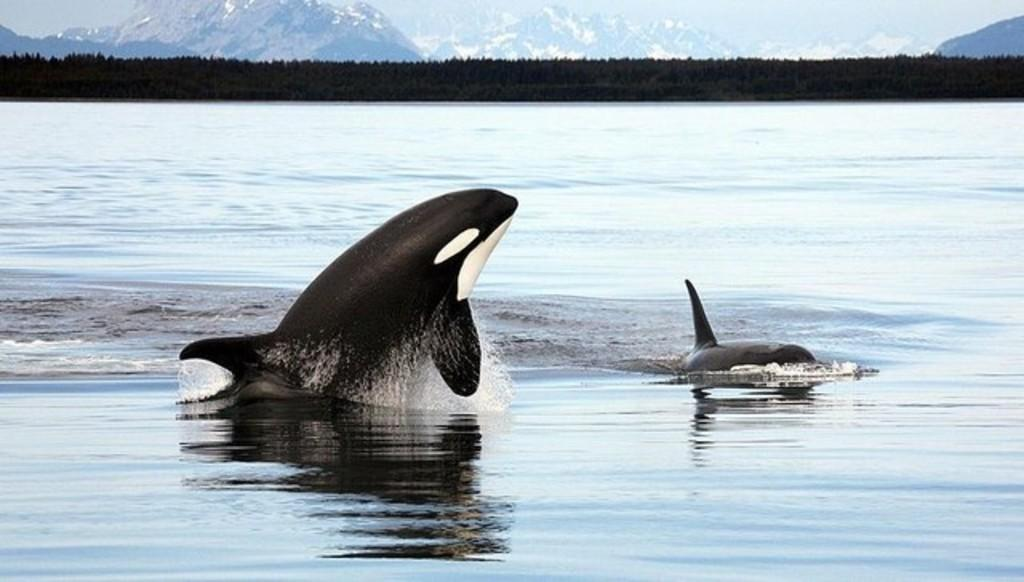What type of animals can be seen in the water in the image? There are dolphins in the water in the image. What type of vegetation is visible in the image? Trees are visible in the image. What type of geological formation can be seen in the image? Mountains are visible in the image. What type of grain is being harvested in the image? There is no grain present in the image; it features dolphins in the water, trees, and mountains. What type of error is being corrected in the image? There is no error present in the image; it is a depiction of dolphins in the water, trees, and mountains. 